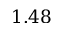Convert formula to latex. <formula><loc_0><loc_0><loc_500><loc_500>1 . 4 8</formula> 